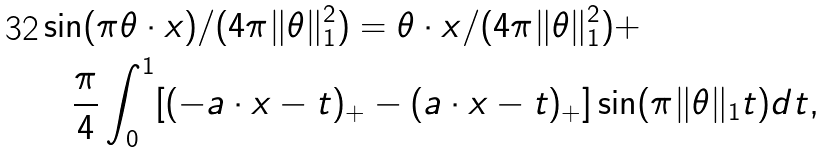<formula> <loc_0><loc_0><loc_500><loc_500>& \sin ( \pi \theta \cdot x ) / ( 4 \pi \| \theta \| ^ { 2 } _ { 1 } ) = \theta \cdot x / ( 4 \pi \| \theta \| ^ { 2 } _ { 1 } ) + \\ & \quad \frac { \pi } { 4 } \int _ { 0 } ^ { 1 } [ ( - a \cdot x - t ) _ { + } - ( a \cdot x - t ) _ { + } ] \sin ( \pi \| \theta \| _ { 1 } t ) d t ,</formula> 